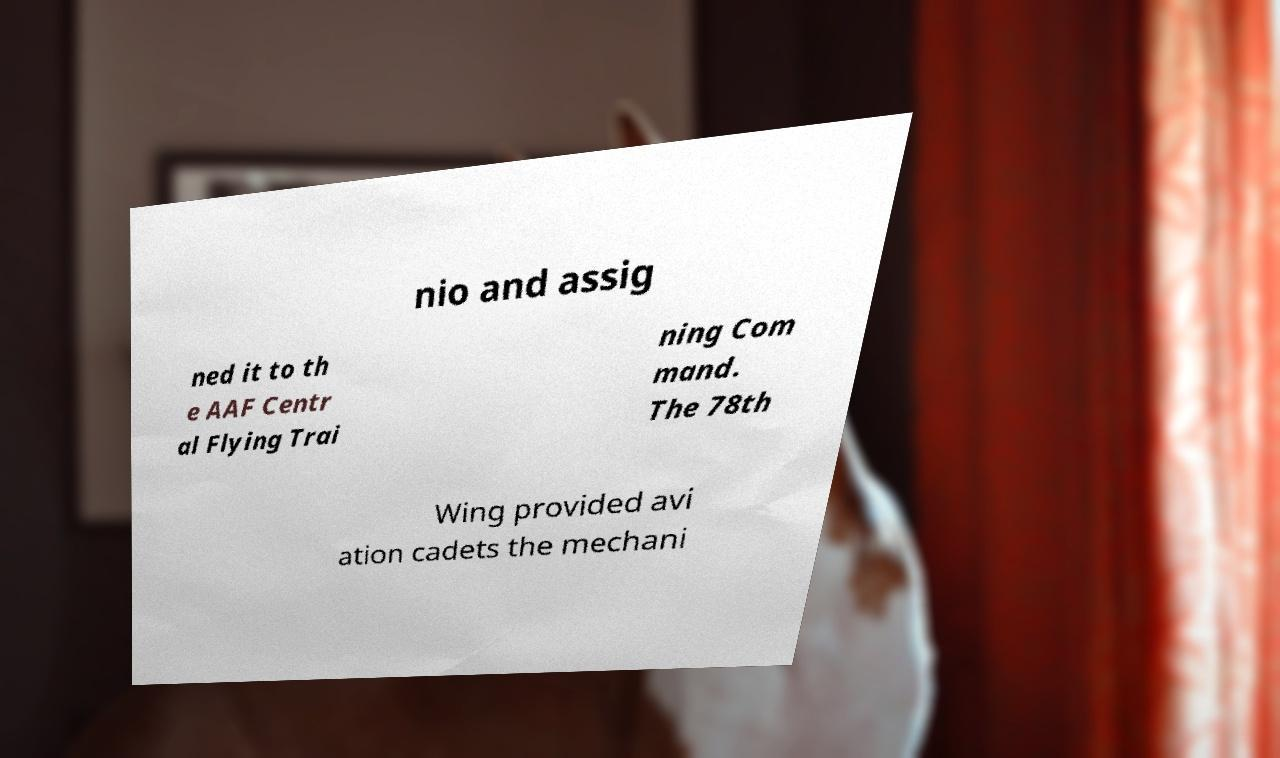What messages or text are displayed in this image? I need them in a readable, typed format. nio and assig ned it to th e AAF Centr al Flying Trai ning Com mand. The 78th Wing provided avi ation cadets the mechani 